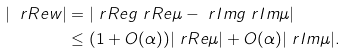<formula> <loc_0><loc_0><loc_500><loc_500>| \ r R e w | & = | \ r R e g \ r R e \mu - \ r I m g \ r I m \mu | \\ & \leq ( 1 + O ( \alpha ) ) | \ r R e \mu | + O ( \alpha ) | \ r I m \mu | .</formula> 